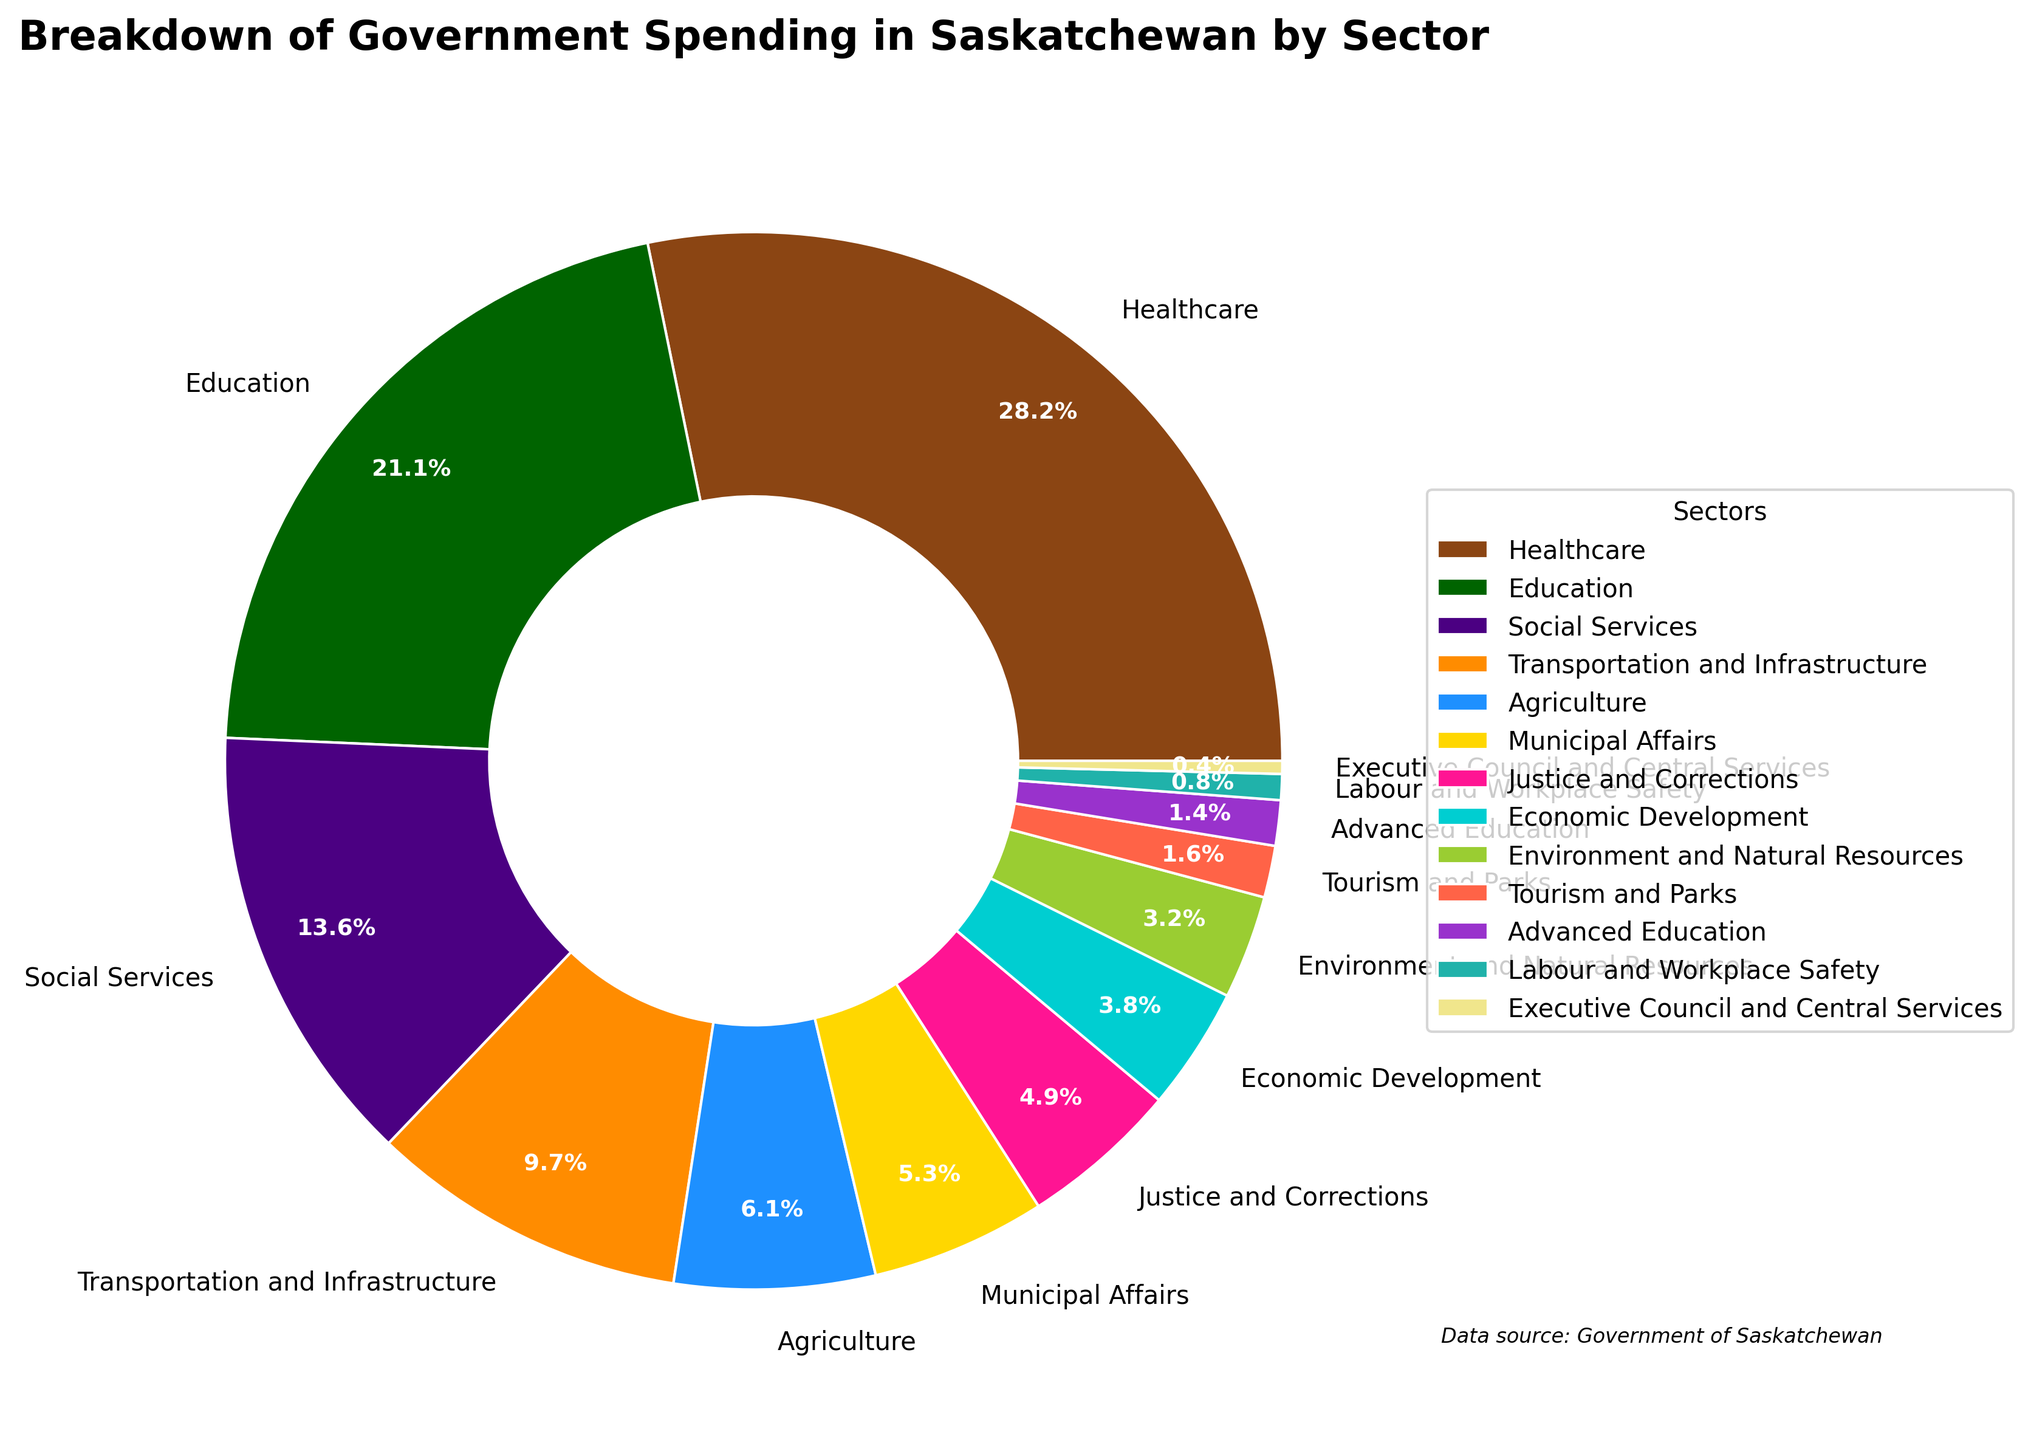What's the percentage of government spending on Healthcare compared to Education? To compare the percentages of Healthcare and Education, look at their respective values in the pie chart. Healthcare has 28.5% and Education has 21.3%.
Answer: Healthcare: 28.5%, Education: 21.3% Which sector receives the least government spending and what is its percentage? Identify the sector with the smallest slice in the pie chart and check the label for its percentage. This will show the sector and the percentage.
Answer: Executive Council and Central Services: 0.4% By how much does spending on Agriculture exceed spending on Labour and Workplace Safety? Look at the pie chart to find the percentages for Agriculture (6.2%) and Labour and Workplace Safety (0.8%). Subtract the smaller percentage from the larger one: 6.2% - 0.8% = 5.4%.
Answer: 5.4% What is the combined percentage of spending on Social Services and Justice and Corrections? Find the percentages of Social Services (13.7%) and Justice and Corrections (4.9%) in the pie chart. Add them together: 13.7% + 4.9% = 18.6%.
Answer: 18.6% How does spending on Economic Development compare to spending on Tourism and Parks? Check the pie chart for Economic Development (3.8%) and Tourism and Parks (1.6%). Economic Development is higher than Tourism and Parks.
Answer: Economic Development: 3.8%, Tourism and Parks: 1.6% Which color represents the Transportation and Infrastructure sector, and what percentage of government spending does it account for? Look for the label of Transportation and Infrastructure in the pie chart and identify both the color and the percentage it has.
Answer: Color: Look at pie chart (often shown as grey), Percentage: 9.8% What is the difference between the percentage of spending on Advanced Education and Municipal Affairs? Find the percentages for Advanced Education (1.4%) and Municipal Affairs (5.4%) in the pie chart. Subtract the smaller percentage from the larger one: 5.4% - 1.4% = 4.0%.
Answer: 4.0% 